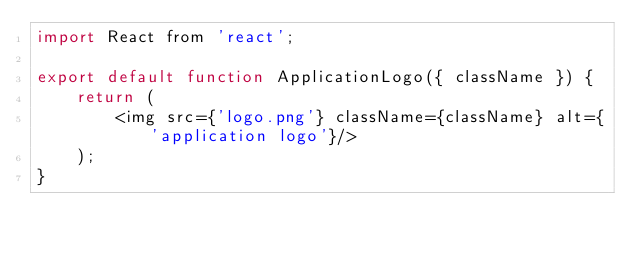Convert code to text. <code><loc_0><loc_0><loc_500><loc_500><_JavaScript_>import React from 'react';

export default function ApplicationLogo({ className }) {
    return (
        <img src={'logo.png'} className={className} alt={'application logo'}/>
    );
}
</code> 